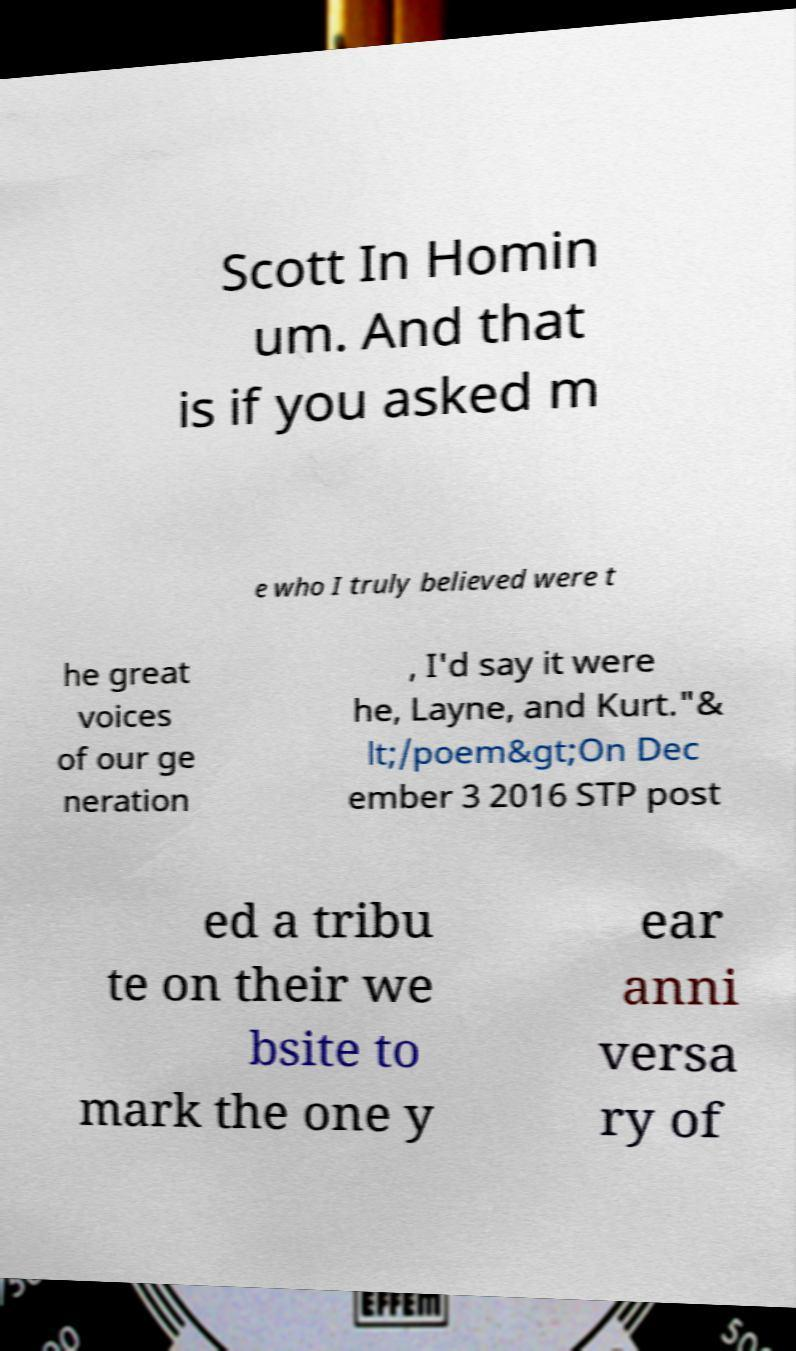Could you extract and type out the text from this image? Scott In Homin um. And that is if you asked m e who I truly believed were t he great voices of our ge neration , I'd say it were he, Layne, and Kurt."& lt;/poem&gt;On Dec ember 3 2016 STP post ed a tribu te on their we bsite to mark the one y ear anni versa ry of 